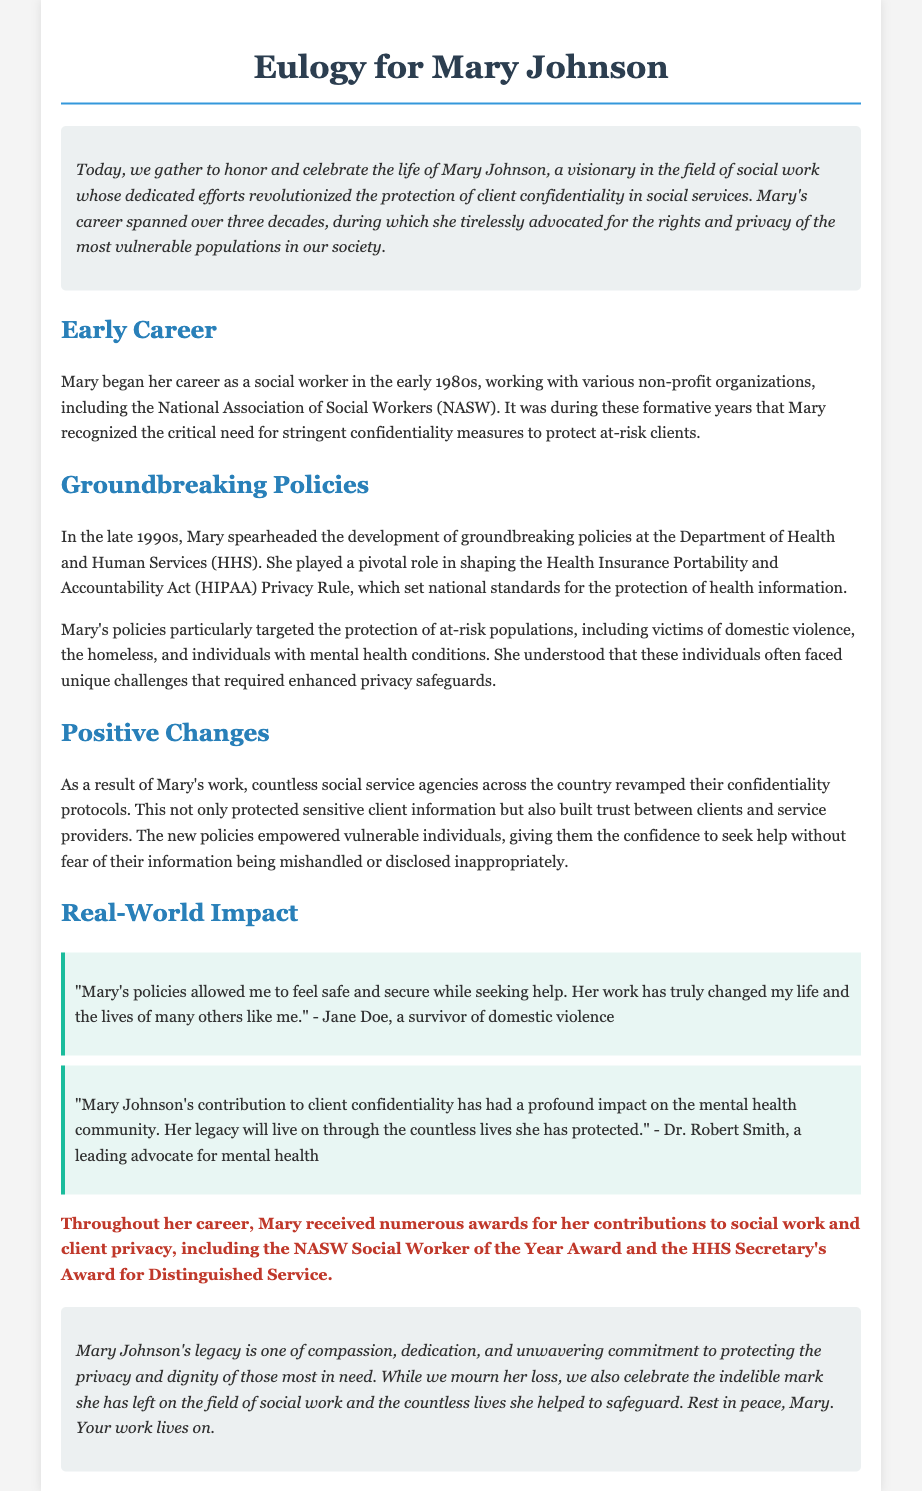What was Mary Johnson's profession? Mary Johnson was a visionary in the field of social work, dedicated to client confidentiality.
Answer: social worker In what decade did Mary start her career? The document states that Mary began her career in the early 1980s.
Answer: 1980s Which policy did Mary help shape? The document indicates that Mary played a pivotal role in shaping the Health Insurance Portability and Accountability Act (HIPAA) Privacy Rule.
Answer: HIPAA Privacy Rule What specific groups did her policies focus on? The document mentions that her policies particularly targeted at-risk populations, including victims of domestic violence, the homeless, and individuals with mental health conditions.
Answer: victims of domestic violence, the homeless, and individuals with mental health conditions Who recognized Mary’s contributions with awards? The document states that Mary received numerous awards, including the NASW Social Worker of the Year Award and the HHS Secretary's Award.
Answer: NASW Social Worker of the Year Award and HHS Secretary's Award What emotional impact did Mary’s policies have on clients? The testimonials highlight that Mary's policies made clients feel safe and secure while seeking help.
Answer: safe and secure What was the overarching theme of Mary Johnson's career? The document emphasizes that Mary Johnson's legacy is about compassion, dedication, and protecting privacy.
Answer: compassion, dedication, and protecting privacy How long did Mary Johnson’s career span? According to the document, Mary’s career spanned over three decades.
Answer: over three decades 